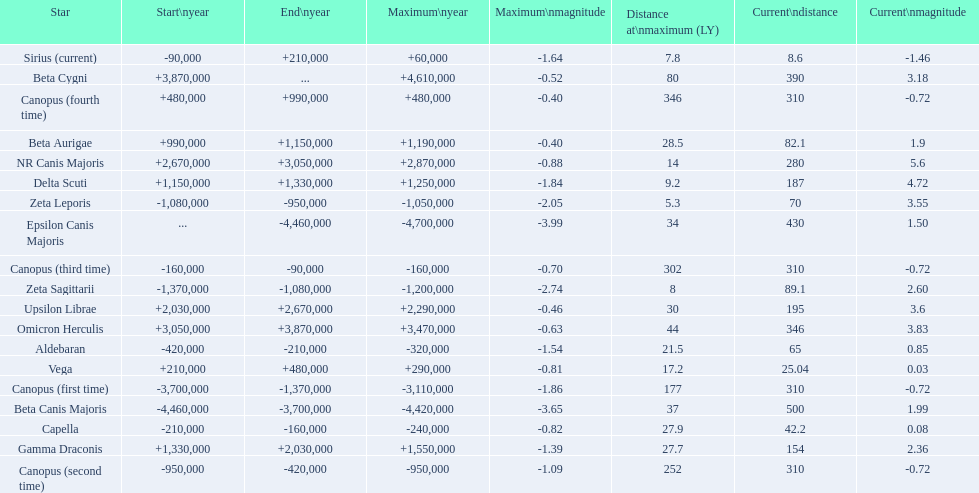What are all the stars? Epsilon Canis Majoris, Beta Canis Majoris, Canopus (first time), Zeta Sagittarii, Zeta Leporis, Canopus (second time), Aldebaran, Capella, Canopus (third time), Sirius (current), Vega, Canopus (fourth time), Beta Aurigae, Delta Scuti, Gamma Draconis, Upsilon Librae, NR Canis Majoris, Omicron Herculis, Beta Cygni. Of those, which star has a maximum distance of 80? Beta Cygni. 